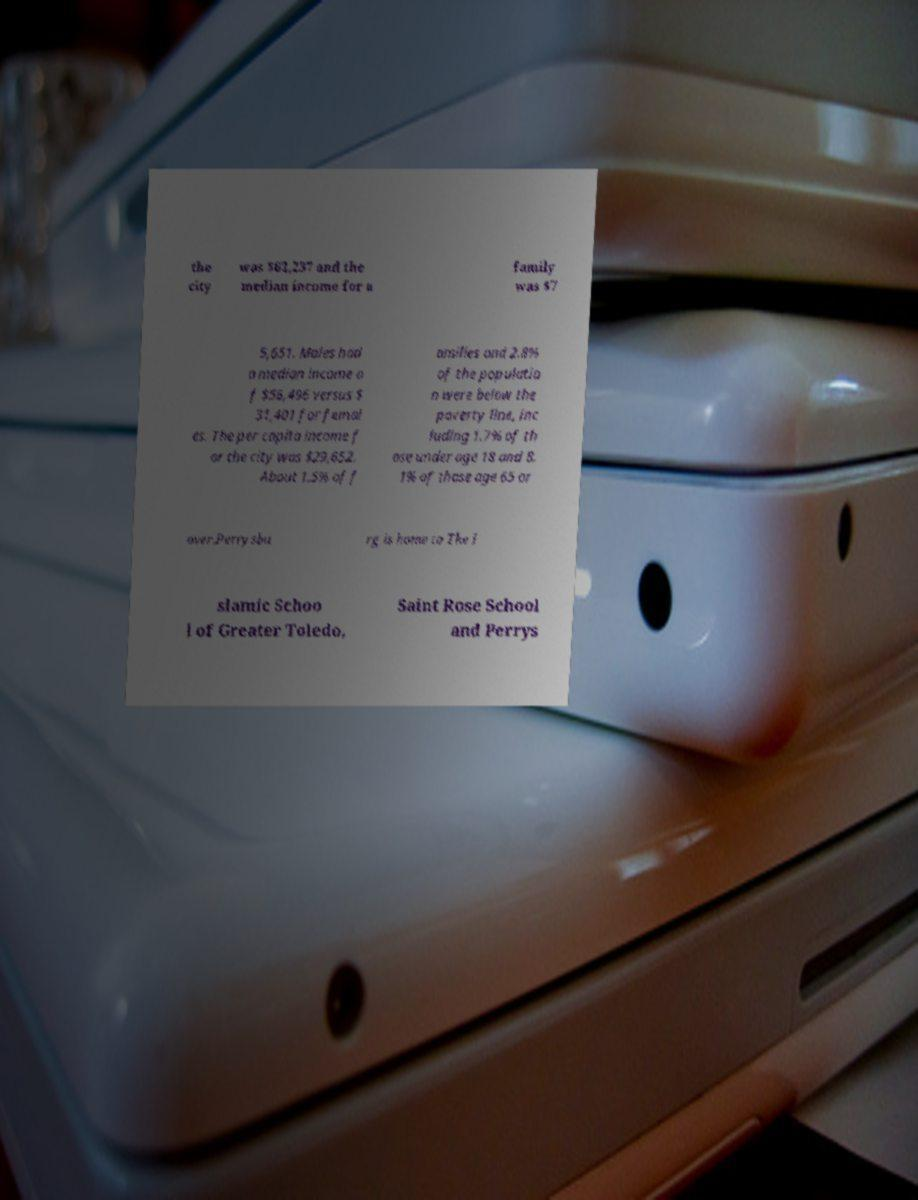Can you accurately transcribe the text from the provided image for me? the city was $62,237 and the median income for a family was $7 5,651. Males had a median income o f $56,496 versus $ 31,401 for femal es. The per capita income f or the city was $29,652. About 1.5% of f amilies and 2.8% of the populatio n were below the poverty line, inc luding 1.7% of th ose under age 18 and 8. 1% of those age 65 or over.Perrysbu rg is home to The I slamic Schoo l of Greater Toledo, Saint Rose School and Perrys 